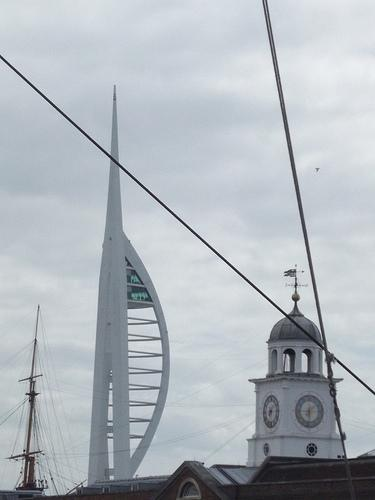Using descriptive language, please highlight the main components of the image. The image features a traditional clock tower with a classic white facade and a gold weathervane atop. In the background, a modern, futuristic tower with a sleek, pointed design stands prominently. Mention the key architectural features found in the image. The image showcases a traditional clock tower with a rounded dome and a weathervane, contrasted by a modern tower with a unique, spire-like design in the background. Summarize the key details of the image in one sentence. The image captures a juxtaposition of architectural styles with a classic clock tower in the foreground and a futuristic spire-like tower in the background. Write a brief description of the objects and their locations in the image. In the foreground, there is a traditional clock tower with a dome and weathervane, while in the background, a modern tower with a distinctive spire shape dominates the skyline. Talk about the main construction in the image and its distinct components. The primary structure in the foreground is a traditional clock tower featuring a dome, a weathervane, and a clock, contrasted against a modern, spire-like tower in the background. Identify the primary architecture and its features in the image. The image features a traditional clock tower with a dome and weathervane in the foreground, and a modern tower with a spire-like design in the background. Mention any identifiable elements on the tower in the image. The foreground tower in the image includes a clock, a dome, and a weathervane, set against a modern tower with a spire-like structure in the background. Describe what the tower in the image looks like and what structures surround it. The foreground features a traditional clock tower with a dome and weathervane, while the background is dominated by a modern tower with a spire-like design. What kind of architectural components can be spotted in the image? The image displays a traditional clock tower with a dome and weathervane, alongside a modern tower with a spire-like structure in the background. In a short description, list the elements present on the tower in this image. The foreground tower in the image features a clock, a dome, and a weathervane, contrasted by a modern spire-like tower in the background. 